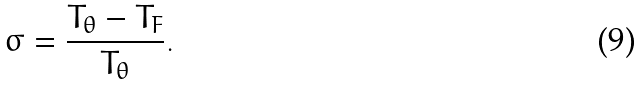<formula> <loc_0><loc_0><loc_500><loc_500>\sigma = \frac { T _ { \theta } - T _ { F } } { T _ { \theta } } .</formula> 